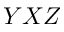<formula> <loc_0><loc_0><loc_500><loc_500>Y X Z</formula> 